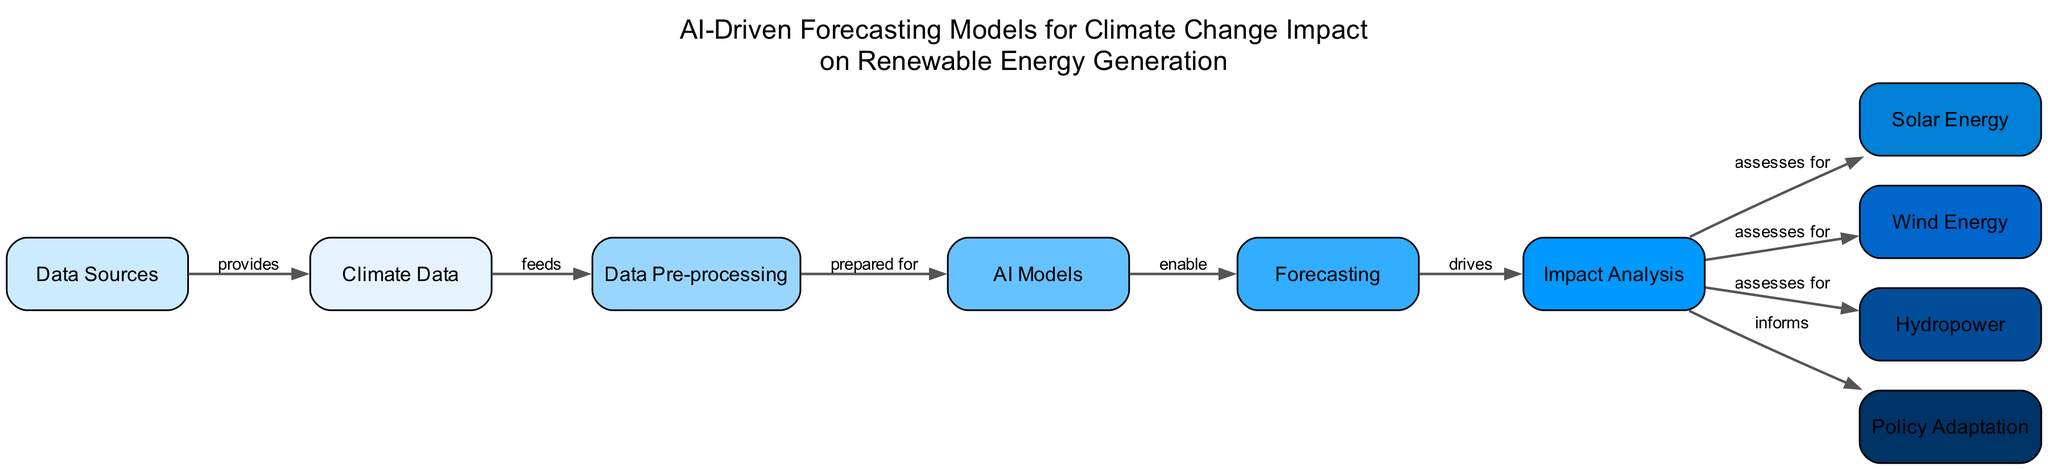What are the main data sources feeding into climate data? The diagram illustrates that the data sources include NOAA, NASA, and IPCC reports, which provide the necessary datasets for analysis.
Answer: NOAA, NASA, IPCC reports How many nodes are there in the diagram? By counting the nodes represented in the diagram, we can determine that there are ten distinct nodes in total, each one representing different aspects of the forecasting model.
Answer: 10 What is the role of AI models in the diagram? In the diagram, AI models are shown as enabling the forecasting process, indicating that they utilize pre-processed data to create predictive models for assessing climate change impacts.
Answer: Enable Which aspect does impact analysis assess for? The impact analysis assesses effects for solar energy, wind energy, and hydropower, highlighting the focus on examining the varying outputs from these renewable sources under climate change scenarios.
Answer: Solar energy, wind energy, hydropower What does impact analysis inform? The diagram indicates that the impact analysis informs policy adaptation, providing guidance for policymakers to address the implications of climate change on renewable energy generation.
Answer: Policy adaptation How does climate data relate to data sources? The relationship depicted in the diagram indicates that data sources supply climate data, which serves as the foundational input for the subsequent analytical process.
Answer: Provides What prepares data for AI models? According to the diagram, data pre-processing is the step that cleans, normalizes, and extracts features from the climate data, making it suitable for the AI models to use.
Answer: Data pre-processing What drives impact analysis in the forecasting process? The forecasting node is shown to drive the impact analysis, meaning that the predictions generated from the AI models are crucial for assessing the potential impacts of climate change on renewable energy generation.
Answer: Drives 